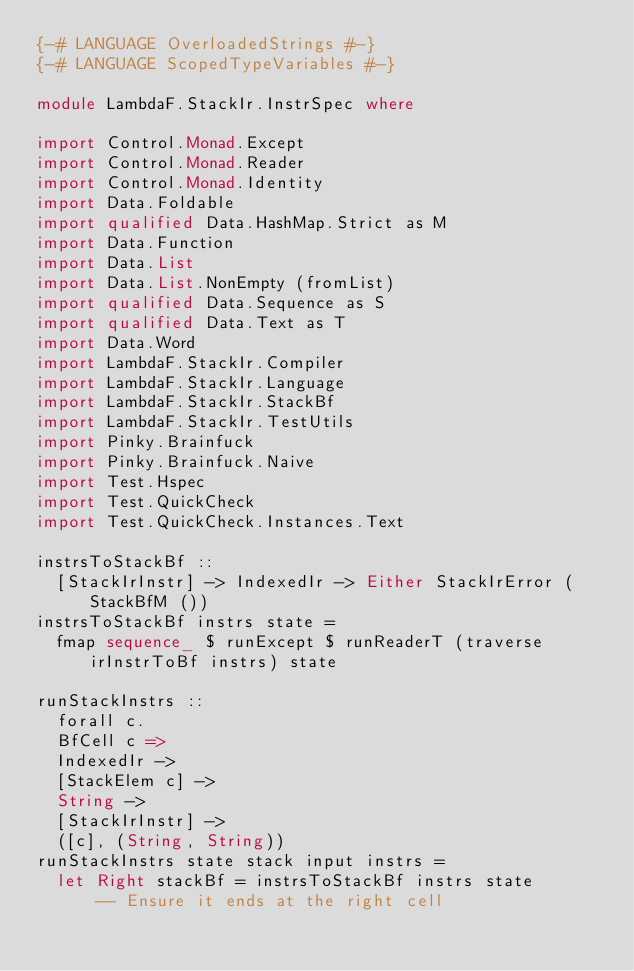Convert code to text. <code><loc_0><loc_0><loc_500><loc_500><_Haskell_>{-# LANGUAGE OverloadedStrings #-}
{-# LANGUAGE ScopedTypeVariables #-}

module LambdaF.StackIr.InstrSpec where

import Control.Monad.Except
import Control.Monad.Reader
import Control.Monad.Identity
import Data.Foldable
import qualified Data.HashMap.Strict as M
import Data.Function
import Data.List
import Data.List.NonEmpty (fromList)
import qualified Data.Sequence as S
import qualified Data.Text as T
import Data.Word
import LambdaF.StackIr.Compiler
import LambdaF.StackIr.Language
import LambdaF.StackIr.StackBf
import LambdaF.StackIr.TestUtils
import Pinky.Brainfuck
import Pinky.Brainfuck.Naive
import Test.Hspec
import Test.QuickCheck
import Test.QuickCheck.Instances.Text

instrsToStackBf ::
  [StackIrInstr] -> IndexedIr -> Either StackIrError (StackBfM ())
instrsToStackBf instrs state =
  fmap sequence_ $ runExcept $ runReaderT (traverse irInstrToBf instrs) state

runStackInstrs ::
  forall c.
  BfCell c =>
  IndexedIr ->
  [StackElem c] ->
  String ->
  [StackIrInstr] ->
  ([c], (String, String))
runStackInstrs state stack input instrs =
  let Right stackBf = instrsToStackBf instrs state
      -- Ensure it ends at the right cell</code> 